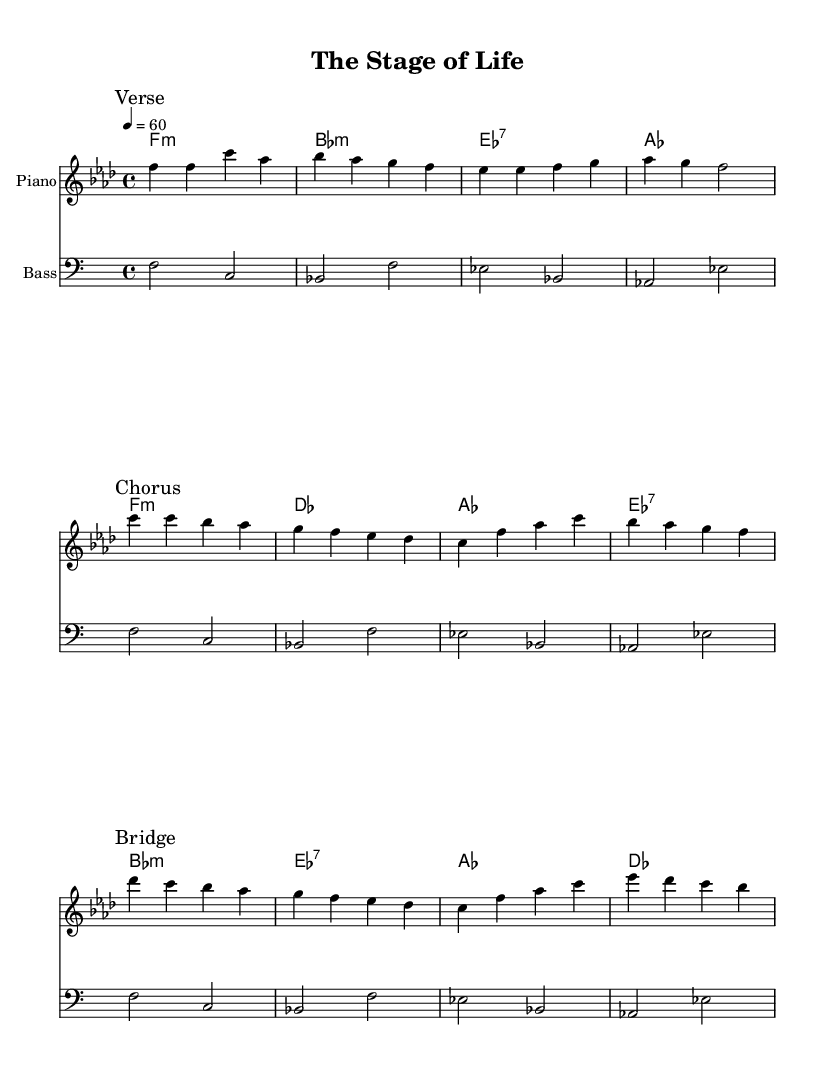What is the key signature of this music? The key signature indicated at the beginning of the score shows one flat, which corresponds to the key of F minor.
Answer: F minor What is the time signature of this music? The time signature provided in the beginning indicates that there are four beats in a measure, denoted as 4/4.
Answer: 4/4 What is the tempo marking for this piece? The tempo marking indicates a quarter note equals sixty beats per minute.
Answer: 60 How many sections are there in the piece? The score displays three marked sections: Verse, Chorus, and Bridge, indicating the structure of the piece.
Answer: Three Which chord follows the first melody line? The first melody line ends on an 'f' note, and the corresponding chord in the harmonies is 'f minor', which matches the melody note.
Answer: f minor In which section does the key of E flat 7 appear? The E flat 7 chord appears in the harmonies during the Chorus section, specifically in the first measure of the Chorus.
Answer: Chorus What is the predominant emotion conveyed by the melody? The melody's movement and harmonies create a soulful and reflective tone, common in emotional ballads about life's journeys, hinting at a deep feeling of introspection.
Answer: Soulful 